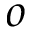Convert formula to latex. <formula><loc_0><loc_0><loc_500><loc_500>o</formula> 